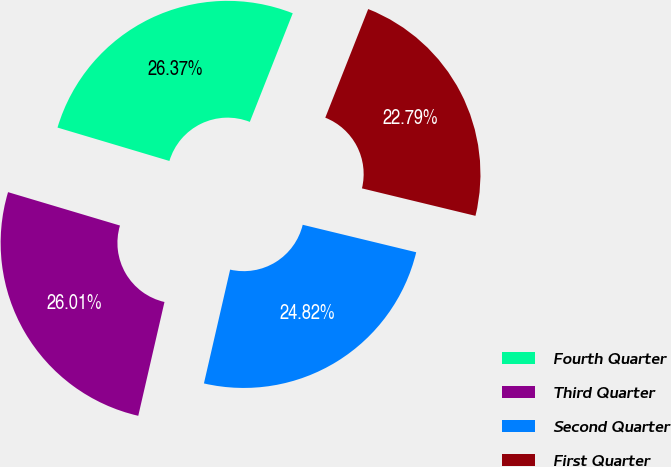Convert chart to OTSL. <chart><loc_0><loc_0><loc_500><loc_500><pie_chart><fcel>Fourth Quarter<fcel>Third Quarter<fcel>Second Quarter<fcel>First Quarter<nl><fcel>26.37%<fcel>26.01%<fcel>24.82%<fcel>22.79%<nl></chart> 